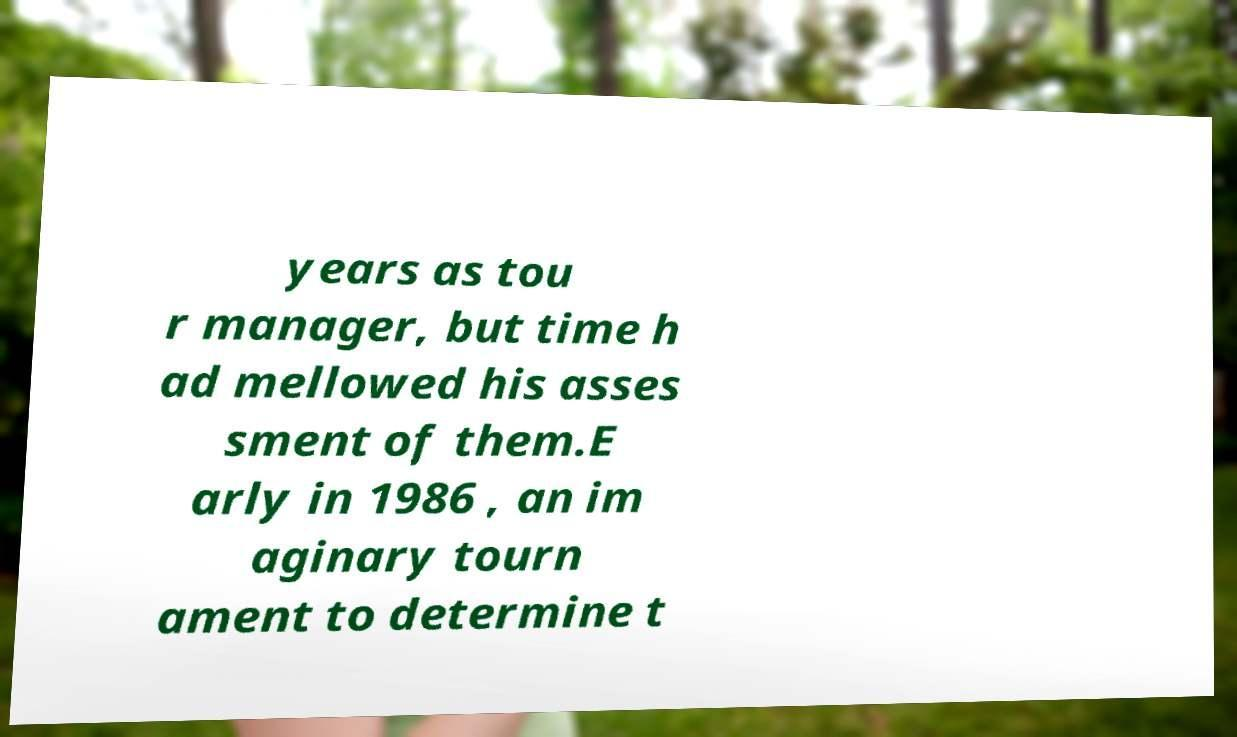Please identify and transcribe the text found in this image. years as tou r manager, but time h ad mellowed his asses sment of them.E arly in 1986 , an im aginary tourn ament to determine t 